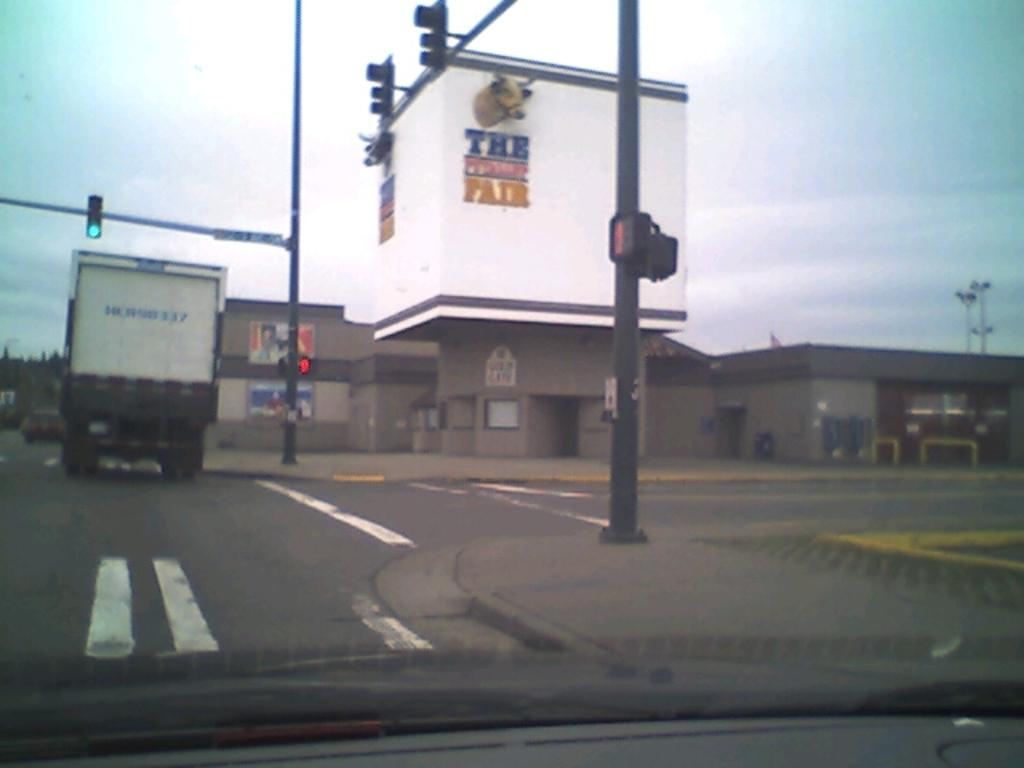What is the main subject in the foreground of the image? There is a vehicle in the foreground of the image. What is the vehicle doing in the image? The vehicle is moving on the road. What else can be seen in the image besides the vehicle? There are poles, buildings, banners, and the sky visible in the image. What type of dress is the vehicle wearing in the image? Vehicles do not wear dresses; they are inanimate objects. 